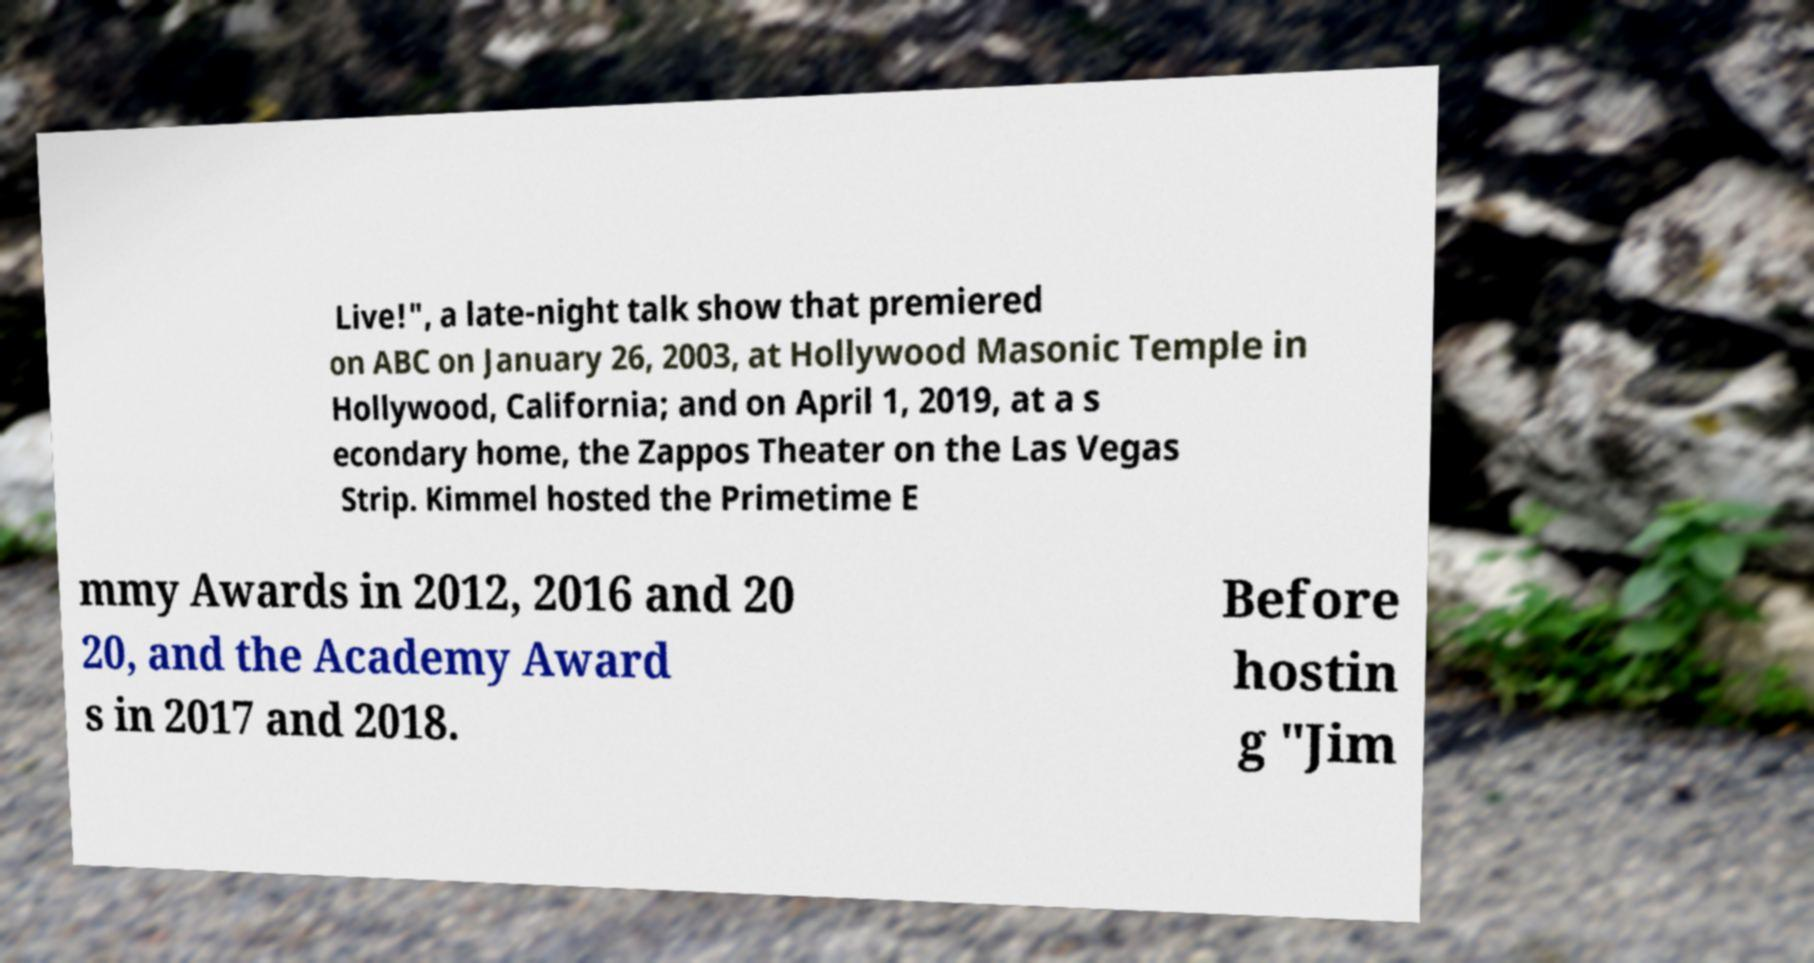Can you read and provide the text displayed in the image?This photo seems to have some interesting text. Can you extract and type it out for me? Live!", a late-night talk show that premiered on ABC on January 26, 2003, at Hollywood Masonic Temple in Hollywood, California; and on April 1, 2019, at a s econdary home, the Zappos Theater on the Las Vegas Strip. Kimmel hosted the Primetime E mmy Awards in 2012, 2016 and 20 20, and the Academy Award s in 2017 and 2018. Before hostin g "Jim 